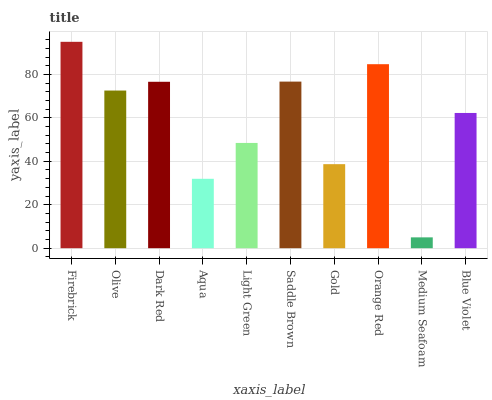Is Medium Seafoam the minimum?
Answer yes or no. Yes. Is Firebrick the maximum?
Answer yes or no. Yes. Is Olive the minimum?
Answer yes or no. No. Is Olive the maximum?
Answer yes or no. No. Is Firebrick greater than Olive?
Answer yes or no. Yes. Is Olive less than Firebrick?
Answer yes or no. Yes. Is Olive greater than Firebrick?
Answer yes or no. No. Is Firebrick less than Olive?
Answer yes or no. No. Is Olive the high median?
Answer yes or no. Yes. Is Blue Violet the low median?
Answer yes or no. Yes. Is Gold the high median?
Answer yes or no. No. Is Dark Red the low median?
Answer yes or no. No. 